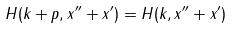Convert formula to latex. <formula><loc_0><loc_0><loc_500><loc_500>H ( k + p , x ^ { \prime \prime } + x ^ { \prime } ) = H ( k , x ^ { \prime \prime } + x ^ { \prime } )</formula> 